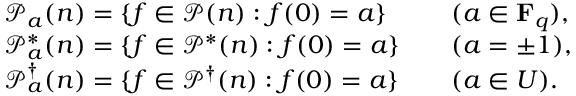<formula> <loc_0><loc_0><loc_500><loc_500>\begin{array} { r l r l } & { \mathcal { P } _ { a } ( n ) = \{ f \in \mathcal { P } ( n ) \colon f ( 0 ) = a \} } & & { ( a \in F _ { q } ) , } \\ & { \mathcal { P } _ { a } ^ { * } ( n ) = \{ f \in \mathcal { P } ^ { * } ( n ) \colon f ( 0 ) = a \} } & & { ( a = \pm 1 ) , } \\ & { \mathcal { P } _ { a } ^ { \dagger } ( n ) = \{ f \in \mathcal { P } ^ { \dagger } ( n ) \colon f ( 0 ) = a \} } & & { ( a \in U ) . } \end{array}</formula> 